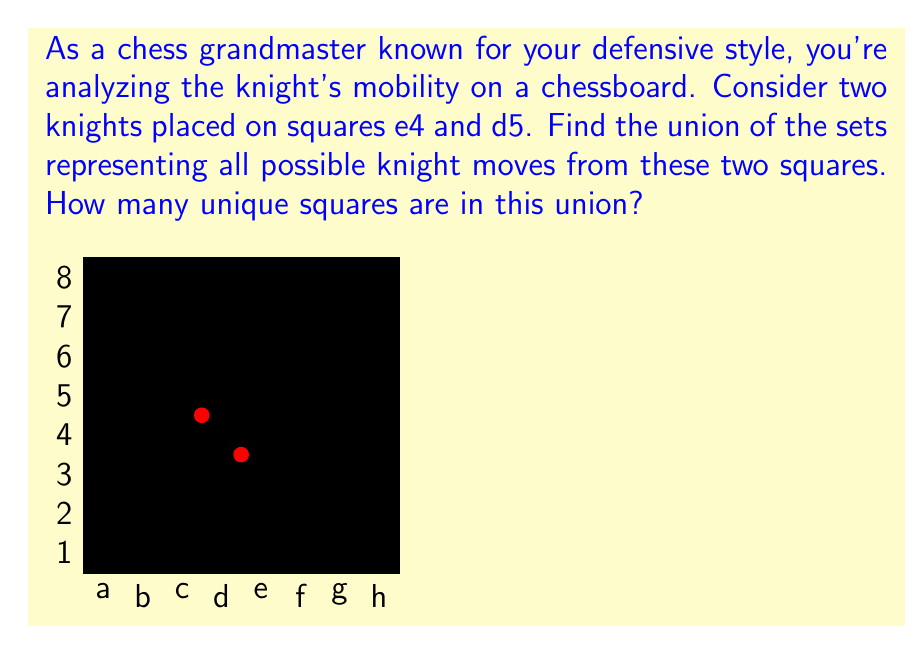Help me with this question. Let's approach this step-by-step:

1) First, let's identify the possible moves for each knight:

   For the knight on e4 (represented as $K_1$):
   $K_1 = \{c3, c5, d2, d6, f2, f6, g3, g5\}$

   For the knight on d5 (represented as $K_2$):
   $K_2 = \{b4, b6, c3, c7, e3, e7, f4, f6\}$

2) Now, we need to find the union of these two sets: $K_1 \cup K_2$

3) To do this, we list all unique elements from both sets:
   $K_1 \cup K_2 = \{b4, b6, c3, c5, c7, d2, d6, e3, e7, f2, f4, f6, g3, g5\}$

4) To count the number of unique squares, we need to be careful not to double-count squares that appear in both sets. In this case, c3 and f6 appear in both $K_1$ and $K_2$.

5) Counting the elements in our union:
   $|K_1 \cup K_2| = 14$

Therefore, there are 14 unique squares in the union of possible knight moves from e4 and d5.
Answer: 14 